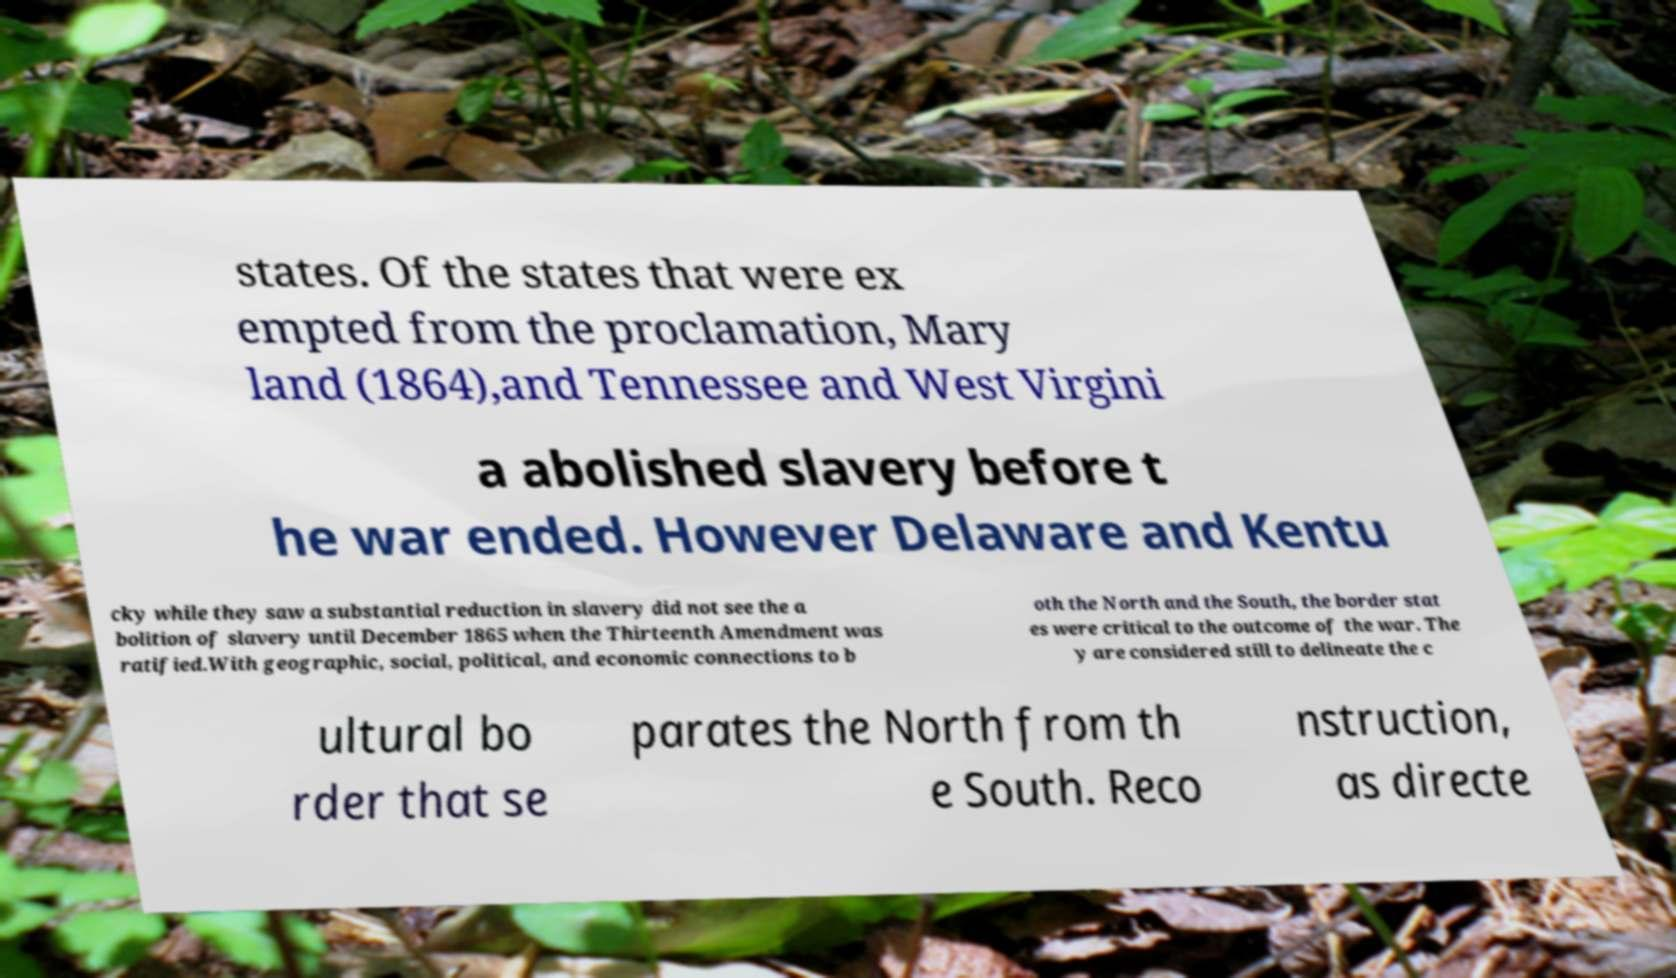What messages or text are displayed in this image? I need them in a readable, typed format. states. Of the states that were ex empted from the proclamation, Mary land (1864),and Tennessee and West Virgini a abolished slavery before t he war ended. However Delaware and Kentu cky while they saw a substantial reduction in slavery did not see the a bolition of slavery until December 1865 when the Thirteenth Amendment was ratified.With geographic, social, political, and economic connections to b oth the North and the South, the border stat es were critical to the outcome of the war. The y are considered still to delineate the c ultural bo rder that se parates the North from th e South. Reco nstruction, as directe 